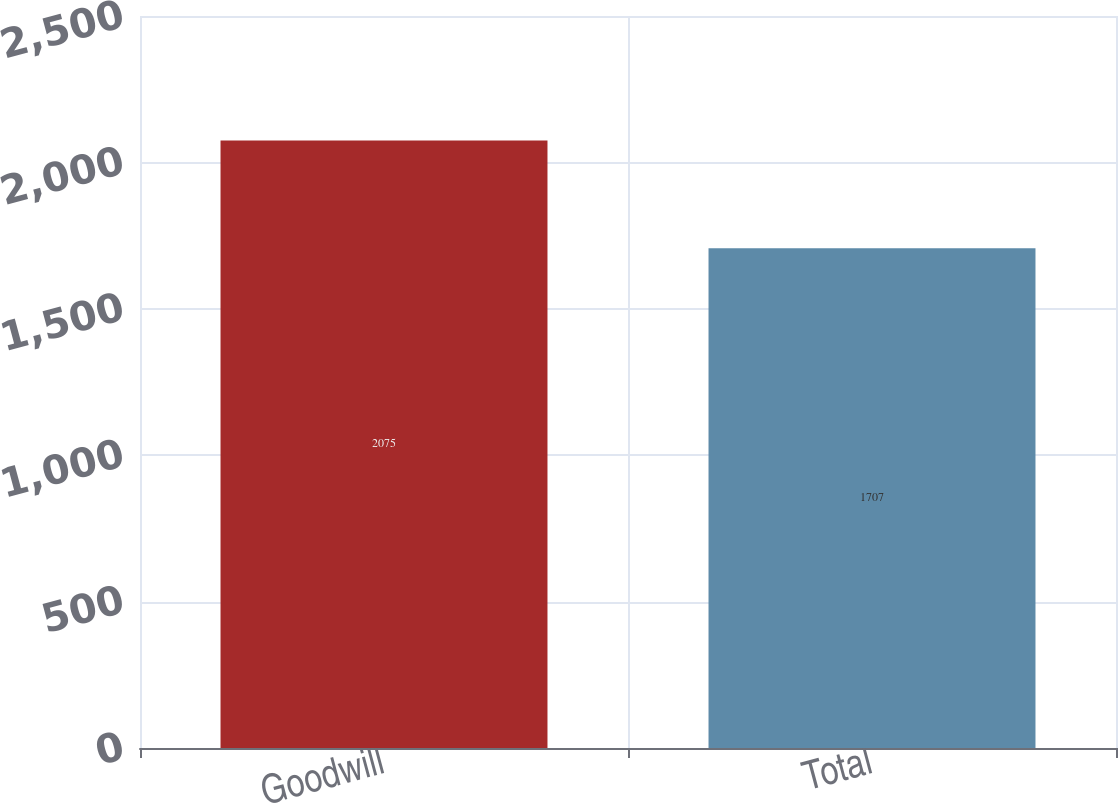Convert chart. <chart><loc_0><loc_0><loc_500><loc_500><bar_chart><fcel>Goodwill<fcel>Total<nl><fcel>2075<fcel>1707<nl></chart> 